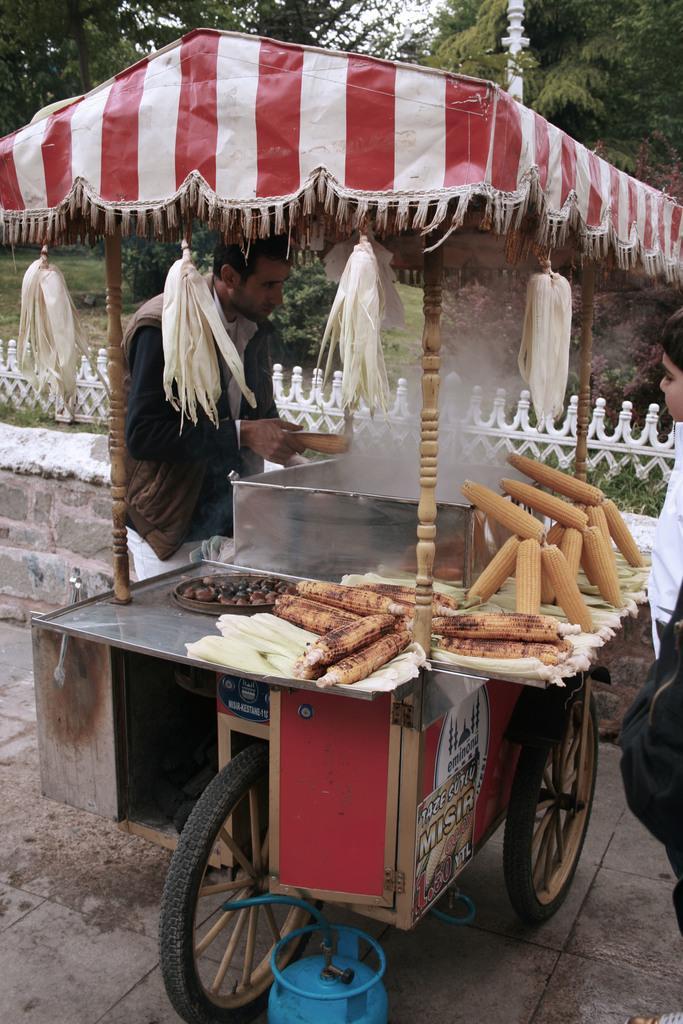Please provide a concise description of this image. In this image in the center there is one person standing, in front of him there is a vehicle and on the vehicle i can see some corns, steel board and some dog is coming out in the center. And on the right side there is another person, in the background there is a fence and some trees. At the bottom there is a walkway and cylinder. 